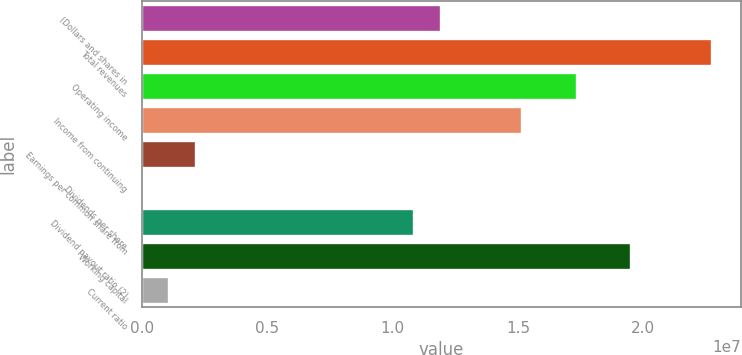<chart> <loc_0><loc_0><loc_500><loc_500><bar_chart><fcel>(Dollars and shares in<fcel>Total revenues<fcel>Operating income<fcel>Income from continuing<fcel>Earnings per common share from<fcel>Dividends per share<fcel>Dividend payout ratio (2)<fcel>Working capital<fcel>Current ratio<nl><fcel>1.19151e+07<fcel>2.2747e+07<fcel>1.7331e+07<fcel>1.51646e+07<fcel>2.16638e+06<fcel>1.11<fcel>1.08319e+07<fcel>1.94974e+07<fcel>1.08319e+06<nl></chart> 